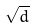<formula> <loc_0><loc_0><loc_500><loc_500>\sqrt { d }</formula> 